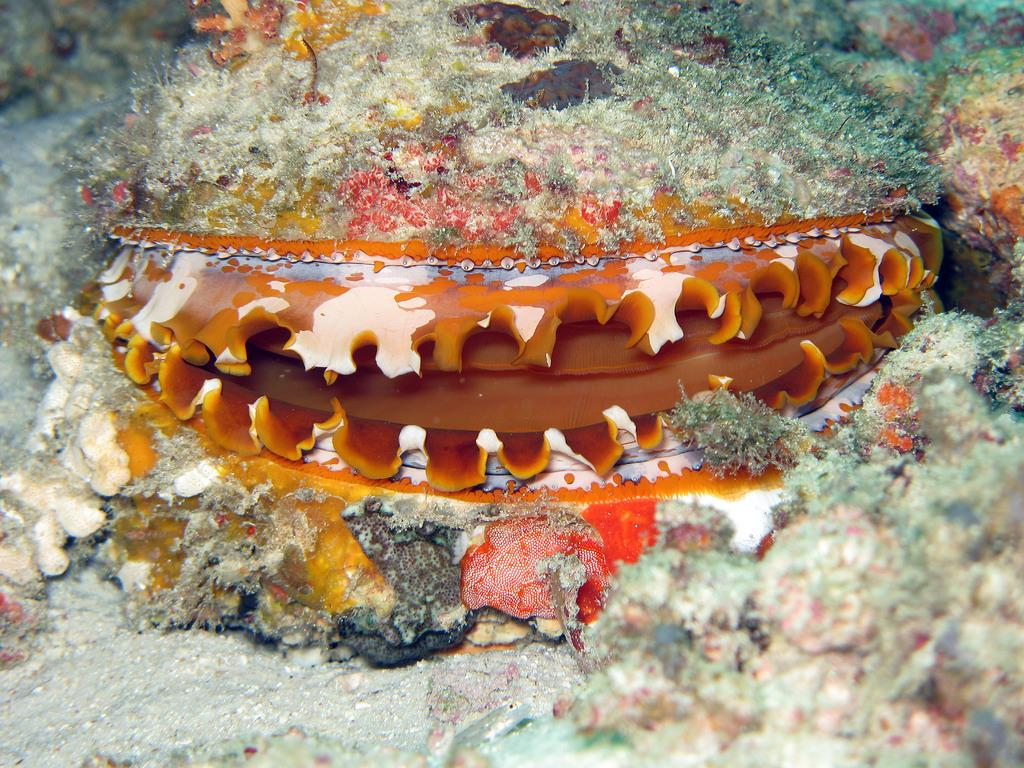What type of animal can be seen in the image? There is a water animal in the image. What type of flower is being held by the baby in the image? There is no baby or flower present in the image; it features a water animal. Is the fan visible in the image turned on or off? There is no fan present in the image. 